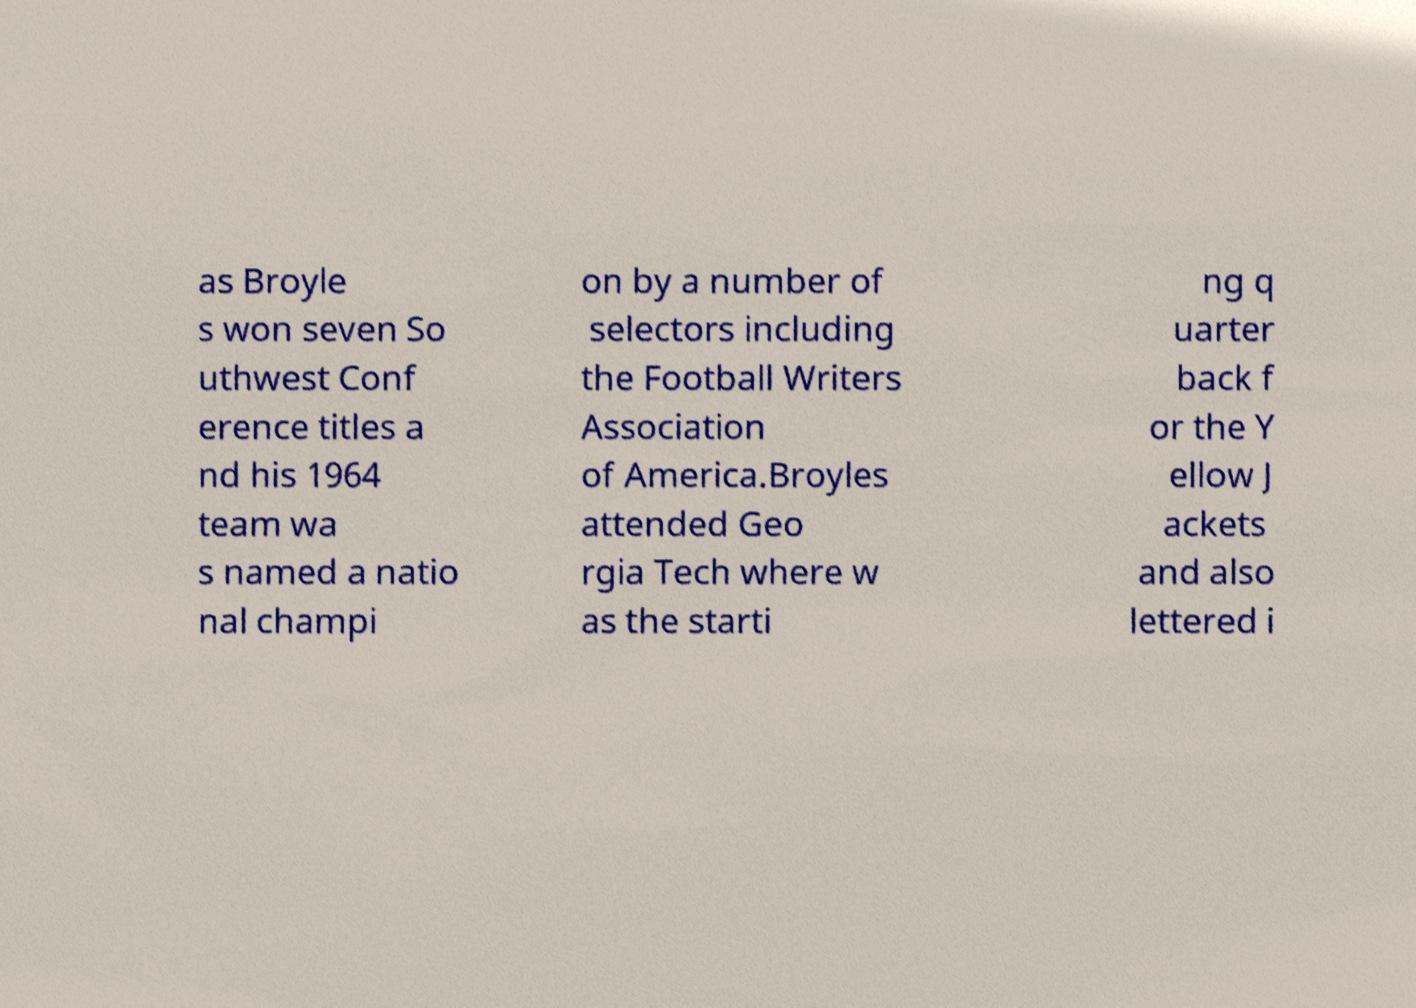Could you assist in decoding the text presented in this image and type it out clearly? as Broyle s won seven So uthwest Conf erence titles a nd his 1964 team wa s named a natio nal champi on by a number of selectors including the Football Writers Association of America.Broyles attended Geo rgia Tech where w as the starti ng q uarter back f or the Y ellow J ackets and also lettered i 